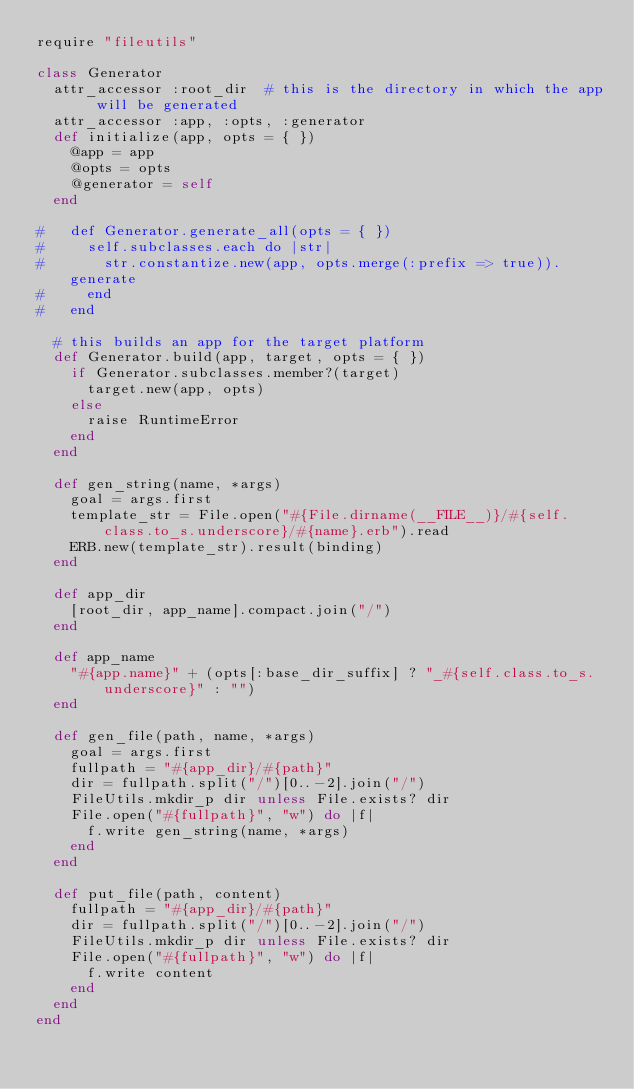<code> <loc_0><loc_0><loc_500><loc_500><_Ruby_>require "fileutils"

class Generator
  attr_accessor :root_dir  # this is the directory in which the app will be generated
  attr_accessor :app, :opts, :generator
  def initialize(app, opts = { })
    @app = app
    @opts = opts
    @generator = self
  end

#   def Generator.generate_all(opts = { })
#     self.subclasses.each do |str|
#       str.constantize.new(app, opts.merge(:prefix => true)).generate
#     end
#   end

  # this builds an app for the target platform
  def Generator.build(app, target, opts = { })
    if Generator.subclasses.member?(target)
      target.new(app, opts)
    else
      raise RuntimeError
    end
  end

  def gen_string(name, *args)
    goal = args.first
    template_str = File.open("#{File.dirname(__FILE__)}/#{self.class.to_s.underscore}/#{name}.erb").read
    ERB.new(template_str).result(binding)
  end

  def app_dir
    [root_dir, app_name].compact.join("/")
  end

  def app_name
    "#{app.name}" + (opts[:base_dir_suffix] ? "_#{self.class.to_s.underscore}" : "")
  end

  def gen_file(path, name, *args)
    goal = args.first
    fullpath = "#{app_dir}/#{path}"
    dir = fullpath.split("/")[0..-2].join("/")
    FileUtils.mkdir_p dir unless File.exists? dir
    File.open("#{fullpath}", "w") do |f|
      f.write gen_string(name, *args)
    end
  end

  def put_file(path, content)
    fullpath = "#{app_dir}/#{path}"
    dir = fullpath.split("/")[0..-2].join("/")
    FileUtils.mkdir_p dir unless File.exists? dir
    File.open("#{fullpath}", "w") do |f|
      f.write content
    end
  end
end
</code> 